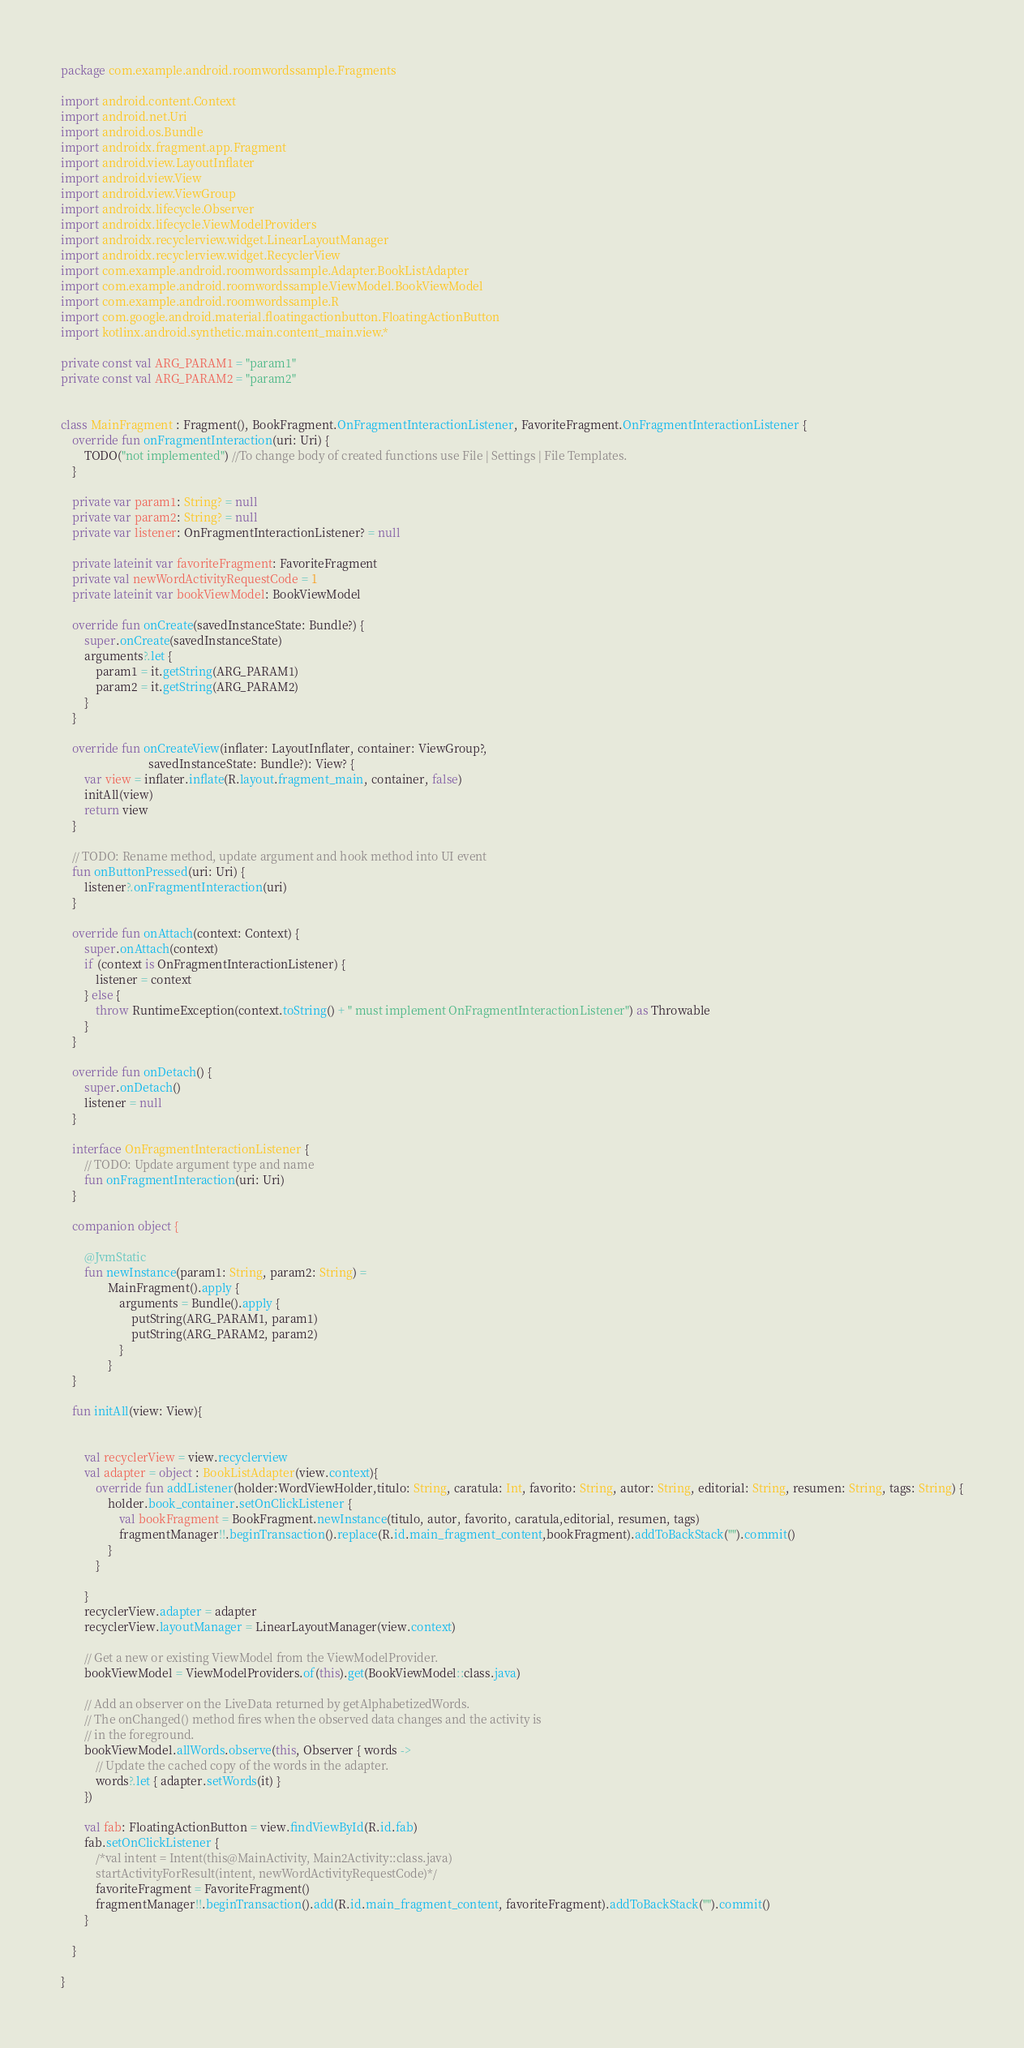Convert code to text. <code><loc_0><loc_0><loc_500><loc_500><_Kotlin_>package com.example.android.roomwordssample.Fragments

import android.content.Context
import android.net.Uri
import android.os.Bundle
import androidx.fragment.app.Fragment
import android.view.LayoutInflater
import android.view.View
import android.view.ViewGroup
import androidx.lifecycle.Observer
import androidx.lifecycle.ViewModelProviders
import androidx.recyclerview.widget.LinearLayoutManager
import androidx.recyclerview.widget.RecyclerView
import com.example.android.roomwordssample.Adapter.BookListAdapter
import com.example.android.roomwordssample.ViewModel.BookViewModel
import com.example.android.roomwordssample.R
import com.google.android.material.floatingactionbutton.FloatingActionButton
import kotlinx.android.synthetic.main.content_main.view.*

private const val ARG_PARAM1 = "param1"
private const val ARG_PARAM2 = "param2"


class MainFragment : Fragment(), BookFragment.OnFragmentInteractionListener, FavoriteFragment.OnFragmentInteractionListener {
    override fun onFragmentInteraction(uri: Uri) {
        TODO("not implemented") //To change body of created functions use File | Settings | File Templates.
    }

    private var param1: String? = null
    private var param2: String? = null
    private var listener: OnFragmentInteractionListener? = null

    private lateinit var favoriteFragment: FavoriteFragment
    private val newWordActivityRequestCode = 1
    private lateinit var bookViewModel: BookViewModel

    override fun onCreate(savedInstanceState: Bundle?) {
        super.onCreate(savedInstanceState)
        arguments?.let {
            param1 = it.getString(ARG_PARAM1)
            param2 = it.getString(ARG_PARAM2)
        }
    }

    override fun onCreateView(inflater: LayoutInflater, container: ViewGroup?,
                              savedInstanceState: Bundle?): View? {
        var view = inflater.inflate(R.layout.fragment_main, container, false)
        initAll(view)
        return view
    }

    // TODO: Rename method, update argument and hook method into UI event
    fun onButtonPressed(uri: Uri) {
        listener?.onFragmentInteraction(uri)
    }

    override fun onAttach(context: Context) {
        super.onAttach(context)
        if (context is OnFragmentInteractionListener) {
            listener = context
        } else {
            throw RuntimeException(context.toString() + " must implement OnFragmentInteractionListener") as Throwable
        }
    }

    override fun onDetach() {
        super.onDetach()
        listener = null
    }

    interface OnFragmentInteractionListener {
        // TODO: Update argument type and name
        fun onFragmentInteraction(uri: Uri)
    }

    companion object {

        @JvmStatic
        fun newInstance(param1: String, param2: String) =
                MainFragment().apply {
                    arguments = Bundle().apply {
                        putString(ARG_PARAM1, param1)
                        putString(ARG_PARAM2, param2)
                    }
                }
    }

    fun initAll(view: View){


        val recyclerView = view.recyclerview
        val adapter = object : BookListAdapter(view.context){
            override fun addListener(holder:WordViewHolder,titulo: String, caratula: Int, favorito: String, autor: String, editorial: String, resumen: String, tags: String) {
                holder.book_container.setOnClickListener {
                    val bookFragment = BookFragment.newInstance(titulo, autor, favorito, caratula,editorial, resumen, tags)
                    fragmentManager!!.beginTransaction().replace(R.id.main_fragment_content,bookFragment).addToBackStack("").commit()
                }
            }

        }
        recyclerView.adapter = adapter
        recyclerView.layoutManager = LinearLayoutManager(view.context)

        // Get a new or existing ViewModel from the ViewModelProvider.
        bookViewModel = ViewModelProviders.of(this).get(BookViewModel::class.java)

        // Add an observer on the LiveData returned by getAlphabetizedWords.
        // The onChanged() method fires when the observed data changes and the activity is
        // in the foreground.
        bookViewModel.allWords.observe(this, Observer { words ->
            // Update the cached copy of the words in the adapter.
            words?.let { adapter.setWords(it) }
        })

        val fab: FloatingActionButton = view.findViewById(R.id.fab)
        fab.setOnClickListener {
            /*val intent = Intent(this@MainActivity, Main2Activity::class.java)
            startActivityForResult(intent, newWordActivityRequestCode)*/
            favoriteFragment = FavoriteFragment()
            fragmentManager!!.beginTransaction().add(R.id.main_fragment_content, favoriteFragment).addToBackStack("").commit()
        }

    }

}
</code> 